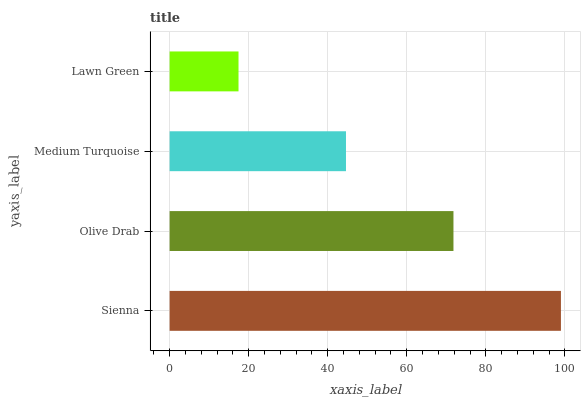Is Lawn Green the minimum?
Answer yes or no. Yes. Is Sienna the maximum?
Answer yes or no. Yes. Is Olive Drab the minimum?
Answer yes or no. No. Is Olive Drab the maximum?
Answer yes or no. No. Is Sienna greater than Olive Drab?
Answer yes or no. Yes. Is Olive Drab less than Sienna?
Answer yes or no. Yes. Is Olive Drab greater than Sienna?
Answer yes or no. No. Is Sienna less than Olive Drab?
Answer yes or no. No. Is Olive Drab the high median?
Answer yes or no. Yes. Is Medium Turquoise the low median?
Answer yes or no. Yes. Is Sienna the high median?
Answer yes or no. No. Is Sienna the low median?
Answer yes or no. No. 